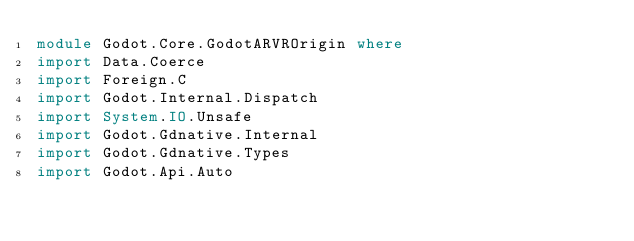Convert code to text. <code><loc_0><loc_0><loc_500><loc_500><_Haskell_>module Godot.Core.GodotARVROrigin where
import Data.Coerce
import Foreign.C
import Godot.Internal.Dispatch
import System.IO.Unsafe
import Godot.Gdnative.Internal
import Godot.Gdnative.Types
import Godot.Api.Auto</code> 